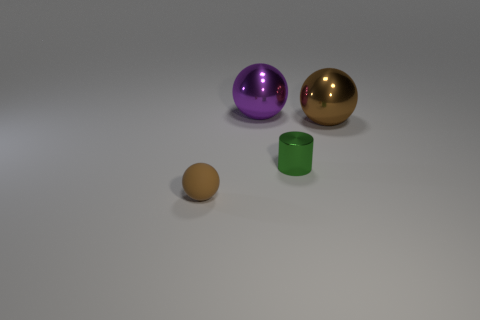Subtract all tiny spheres. How many spheres are left? 2 Add 1 shiny cylinders. How many objects exist? 5 Subtract all purple balls. How many balls are left? 2 Subtract all spheres. How many objects are left? 1 Subtract all cyan blocks. How many brown spheres are left? 2 Subtract all brown metallic balls. Subtract all big objects. How many objects are left? 1 Add 4 big purple objects. How many big purple objects are left? 5 Add 2 large cyan metal spheres. How many large cyan metal spheres exist? 2 Subtract 0 red cylinders. How many objects are left? 4 Subtract 3 balls. How many balls are left? 0 